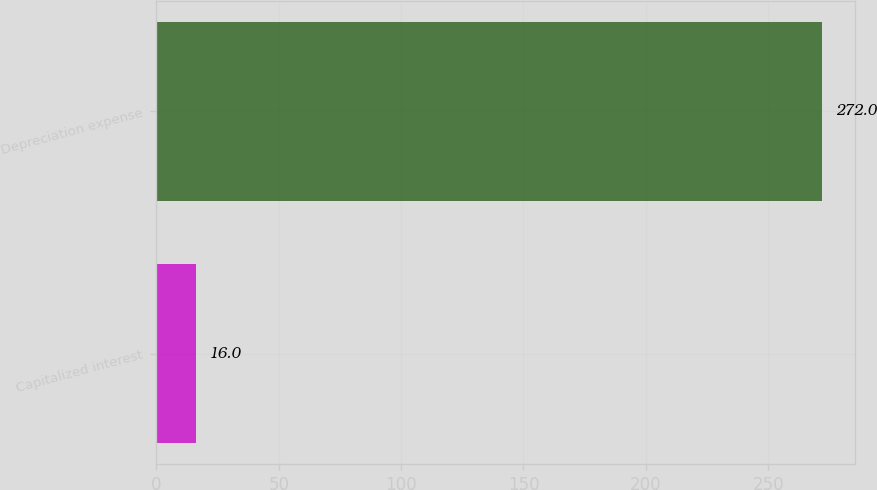<chart> <loc_0><loc_0><loc_500><loc_500><bar_chart><fcel>Capitalized interest<fcel>Depreciation expense<nl><fcel>16<fcel>272<nl></chart> 